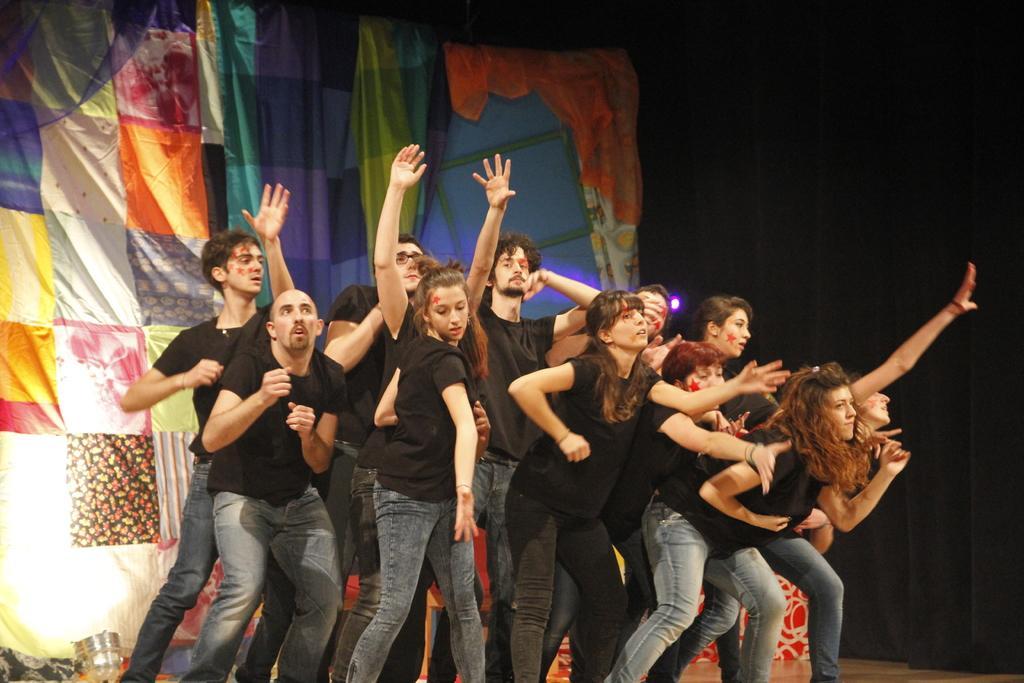How would you summarize this image in a sentence or two? People are present wearing black t shirt and jeans. There is a colorful background and a black background at the right. 